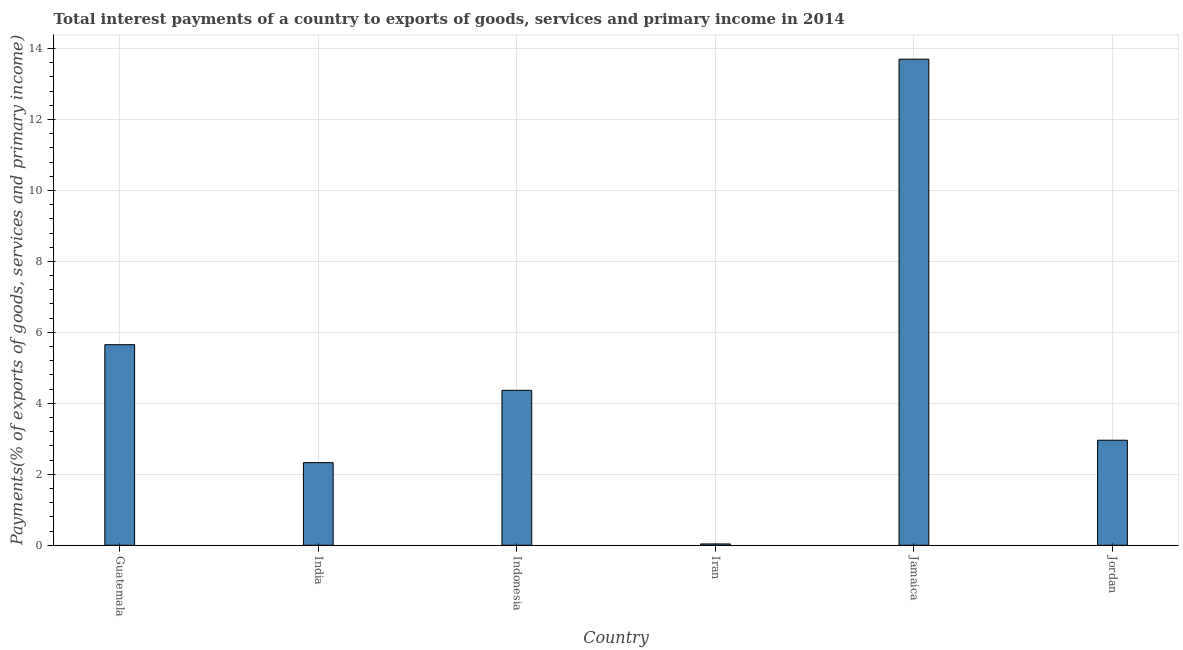What is the title of the graph?
Your answer should be very brief. Total interest payments of a country to exports of goods, services and primary income in 2014. What is the label or title of the Y-axis?
Provide a succinct answer. Payments(% of exports of goods, services and primary income). What is the total interest payments on external debt in Guatemala?
Offer a terse response. 5.65. Across all countries, what is the maximum total interest payments on external debt?
Offer a terse response. 13.7. Across all countries, what is the minimum total interest payments on external debt?
Offer a terse response. 0.04. In which country was the total interest payments on external debt maximum?
Keep it short and to the point. Jamaica. In which country was the total interest payments on external debt minimum?
Ensure brevity in your answer.  Iran. What is the sum of the total interest payments on external debt?
Keep it short and to the point. 29.04. What is the difference between the total interest payments on external debt in Indonesia and Jamaica?
Your response must be concise. -9.33. What is the average total interest payments on external debt per country?
Make the answer very short. 4.84. What is the median total interest payments on external debt?
Your answer should be compact. 3.66. What is the ratio of the total interest payments on external debt in Indonesia to that in Jordan?
Offer a very short reply. 1.48. Is the total interest payments on external debt in Guatemala less than that in Indonesia?
Ensure brevity in your answer.  No. What is the difference between the highest and the second highest total interest payments on external debt?
Offer a terse response. 8.05. What is the difference between the highest and the lowest total interest payments on external debt?
Offer a very short reply. 13.66. In how many countries, is the total interest payments on external debt greater than the average total interest payments on external debt taken over all countries?
Your answer should be compact. 2. What is the Payments(% of exports of goods, services and primary income) of Guatemala?
Your response must be concise. 5.65. What is the Payments(% of exports of goods, services and primary income) in India?
Your answer should be compact. 2.33. What is the Payments(% of exports of goods, services and primary income) in Indonesia?
Your answer should be compact. 4.37. What is the Payments(% of exports of goods, services and primary income) in Iran?
Offer a very short reply. 0.04. What is the Payments(% of exports of goods, services and primary income) of Jamaica?
Keep it short and to the point. 13.7. What is the Payments(% of exports of goods, services and primary income) of Jordan?
Make the answer very short. 2.96. What is the difference between the Payments(% of exports of goods, services and primary income) in Guatemala and India?
Your answer should be compact. 3.32. What is the difference between the Payments(% of exports of goods, services and primary income) in Guatemala and Indonesia?
Your answer should be very brief. 1.29. What is the difference between the Payments(% of exports of goods, services and primary income) in Guatemala and Iran?
Offer a very short reply. 5.61. What is the difference between the Payments(% of exports of goods, services and primary income) in Guatemala and Jamaica?
Your answer should be compact. -8.05. What is the difference between the Payments(% of exports of goods, services and primary income) in Guatemala and Jordan?
Your answer should be very brief. 2.69. What is the difference between the Payments(% of exports of goods, services and primary income) in India and Indonesia?
Ensure brevity in your answer.  -2.04. What is the difference between the Payments(% of exports of goods, services and primary income) in India and Iran?
Keep it short and to the point. 2.29. What is the difference between the Payments(% of exports of goods, services and primary income) in India and Jamaica?
Ensure brevity in your answer.  -11.37. What is the difference between the Payments(% of exports of goods, services and primary income) in India and Jordan?
Your answer should be very brief. -0.63. What is the difference between the Payments(% of exports of goods, services and primary income) in Indonesia and Iran?
Provide a succinct answer. 4.33. What is the difference between the Payments(% of exports of goods, services and primary income) in Indonesia and Jamaica?
Give a very brief answer. -9.33. What is the difference between the Payments(% of exports of goods, services and primary income) in Indonesia and Jordan?
Your answer should be very brief. 1.41. What is the difference between the Payments(% of exports of goods, services and primary income) in Iran and Jamaica?
Your answer should be very brief. -13.66. What is the difference between the Payments(% of exports of goods, services and primary income) in Iran and Jordan?
Offer a terse response. -2.92. What is the difference between the Payments(% of exports of goods, services and primary income) in Jamaica and Jordan?
Offer a terse response. 10.74. What is the ratio of the Payments(% of exports of goods, services and primary income) in Guatemala to that in India?
Give a very brief answer. 2.43. What is the ratio of the Payments(% of exports of goods, services and primary income) in Guatemala to that in Indonesia?
Keep it short and to the point. 1.29. What is the ratio of the Payments(% of exports of goods, services and primary income) in Guatemala to that in Iran?
Your answer should be compact. 149.58. What is the ratio of the Payments(% of exports of goods, services and primary income) in Guatemala to that in Jamaica?
Provide a succinct answer. 0.41. What is the ratio of the Payments(% of exports of goods, services and primary income) in Guatemala to that in Jordan?
Your answer should be compact. 1.91. What is the ratio of the Payments(% of exports of goods, services and primary income) in India to that in Indonesia?
Keep it short and to the point. 0.53. What is the ratio of the Payments(% of exports of goods, services and primary income) in India to that in Iran?
Your response must be concise. 61.62. What is the ratio of the Payments(% of exports of goods, services and primary income) in India to that in Jamaica?
Keep it short and to the point. 0.17. What is the ratio of the Payments(% of exports of goods, services and primary income) in India to that in Jordan?
Provide a succinct answer. 0.79. What is the ratio of the Payments(% of exports of goods, services and primary income) in Indonesia to that in Iran?
Provide a short and direct response. 115.53. What is the ratio of the Payments(% of exports of goods, services and primary income) in Indonesia to that in Jamaica?
Make the answer very short. 0.32. What is the ratio of the Payments(% of exports of goods, services and primary income) in Indonesia to that in Jordan?
Offer a very short reply. 1.48. What is the ratio of the Payments(% of exports of goods, services and primary income) in Iran to that in Jamaica?
Offer a terse response. 0. What is the ratio of the Payments(% of exports of goods, services and primary income) in Iran to that in Jordan?
Your answer should be very brief. 0.01. What is the ratio of the Payments(% of exports of goods, services and primary income) in Jamaica to that in Jordan?
Your answer should be very brief. 4.63. 